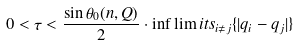Convert formula to latex. <formula><loc_0><loc_0><loc_500><loc_500>0 < \tau < \frac { \sin \theta _ { 0 } ( n , Q ) } { 2 } \cdot \inf \lim i t s _ { i \ne j } \{ | q _ { i } - q _ { j } | \}</formula> 